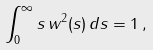Convert formula to latex. <formula><loc_0><loc_0><loc_500><loc_500>\int _ { 0 } ^ { \infty } s \, w ^ { 2 } ( s ) \, d s = 1 \, ,</formula> 